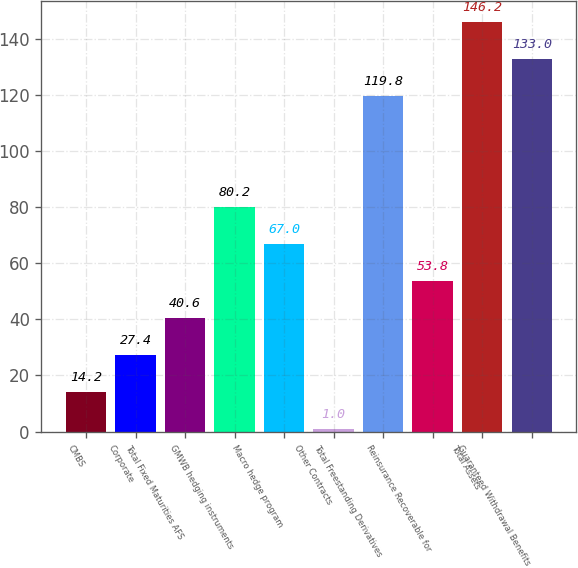<chart> <loc_0><loc_0><loc_500><loc_500><bar_chart><fcel>CMBS<fcel>Corporate<fcel>Total Fixed Maturities AFS<fcel>GMWB hedging instruments<fcel>Macro hedge program<fcel>Other Contracts<fcel>Total Freestanding Derivatives<fcel>Reinsurance Recoverable for<fcel>Total Assets<fcel>Guaranteed Withdrawal Benefits<nl><fcel>14.2<fcel>27.4<fcel>40.6<fcel>80.2<fcel>67<fcel>1<fcel>119.8<fcel>53.8<fcel>146.2<fcel>133<nl></chart> 